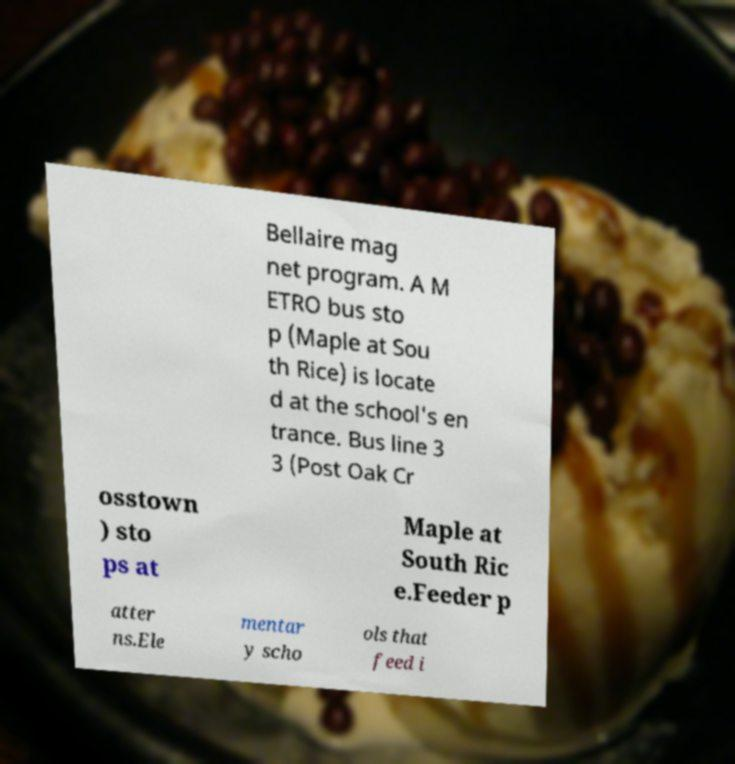What messages or text are displayed in this image? I need them in a readable, typed format. Bellaire mag net program. A M ETRO bus sto p (Maple at Sou th Rice) is locate d at the school's en trance. Bus line 3 3 (Post Oak Cr osstown ) sto ps at Maple at South Ric e.Feeder p atter ns.Ele mentar y scho ols that feed i 